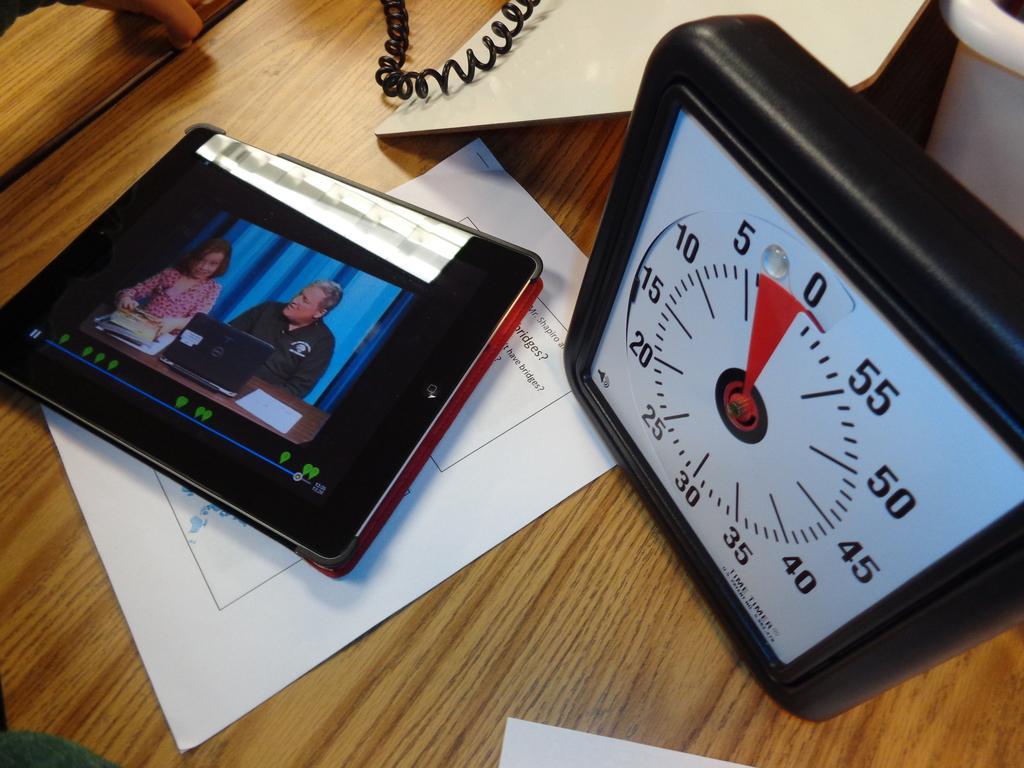Can you describe this image briefly? In this image, we can see an iPad, paper, meter, some objects are placed on the wooden surface. In the screen, we can see laptop, woman and man. Here we can see woman is holding some objects. 